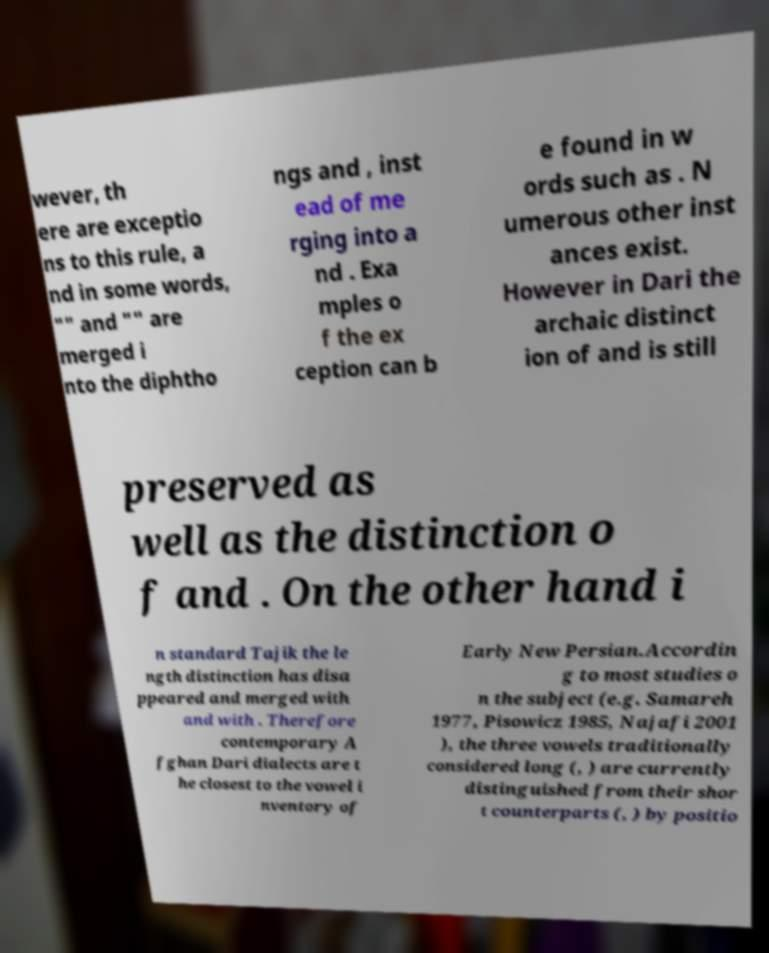What messages or text are displayed in this image? I need them in a readable, typed format. wever, th ere are exceptio ns to this rule, a nd in some words, "" and "" are merged i nto the diphtho ngs and , inst ead of me rging into a nd . Exa mples o f the ex ception can b e found in w ords such as . N umerous other inst ances exist. However in Dari the archaic distinct ion of and is still preserved as well as the distinction o f and . On the other hand i n standard Tajik the le ngth distinction has disa ppeared and merged with and with . Therefore contemporary A fghan Dari dialects are t he closest to the vowel i nventory of Early New Persian.Accordin g to most studies o n the subject (e.g. Samareh 1977, Pisowicz 1985, Najafi 2001 ), the three vowels traditionally considered long (, ) are currently distinguished from their shor t counterparts (, ) by positio 